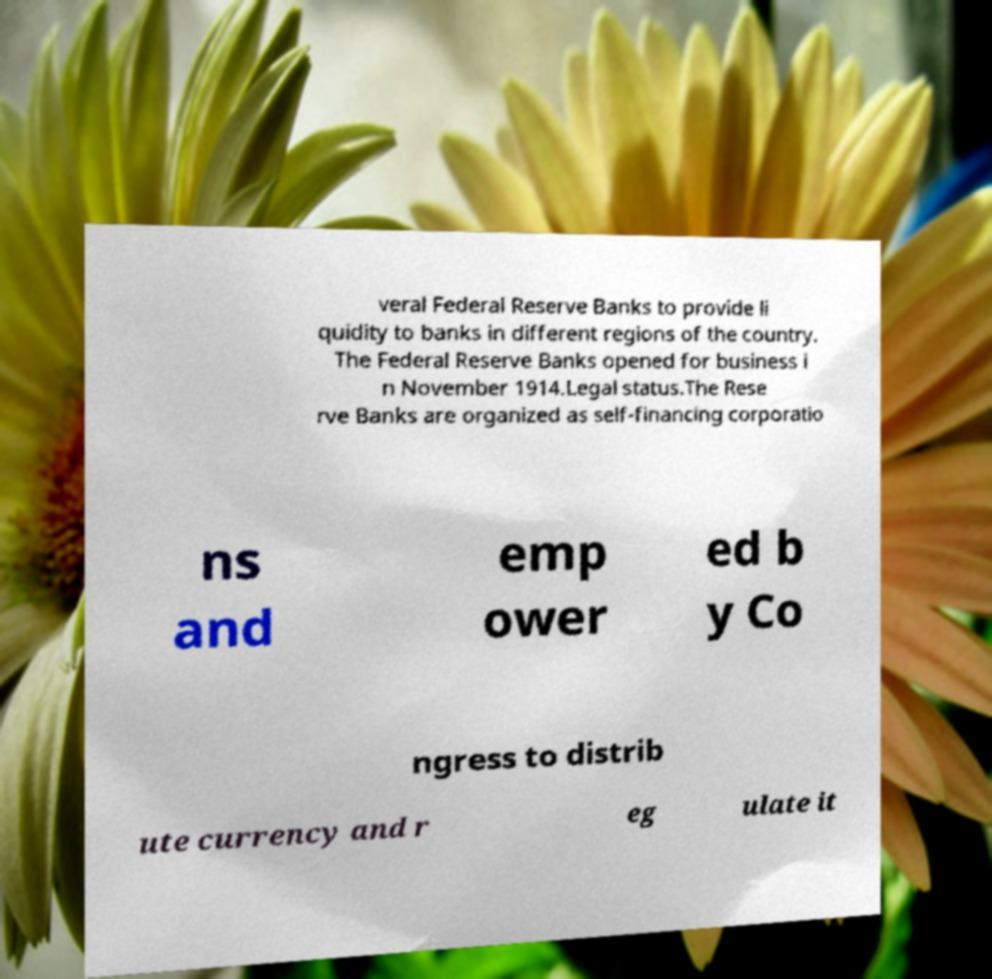Could you extract and type out the text from this image? veral Federal Reserve Banks to provide li quidity to banks in different regions of the country. The Federal Reserve Banks opened for business i n November 1914.Legal status.The Rese rve Banks are organized as self-financing corporatio ns and emp ower ed b y Co ngress to distrib ute currency and r eg ulate it 